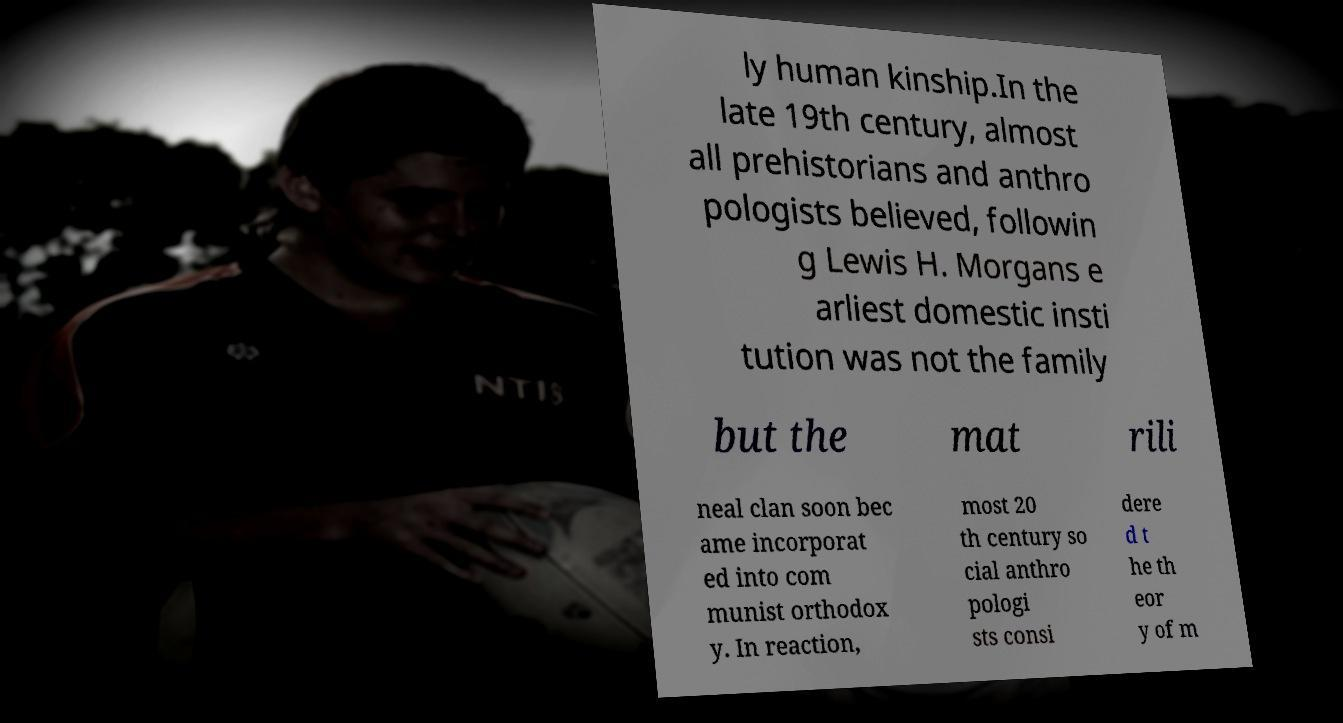Can you accurately transcribe the text from the provided image for me? ly human kinship.In the late 19th century, almost all prehistorians and anthro pologists believed, followin g Lewis H. Morgans e arliest domestic insti tution was not the family but the mat rili neal clan soon bec ame incorporat ed into com munist orthodox y. In reaction, most 20 th century so cial anthro pologi sts consi dere d t he th eor y of m 